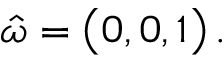Convert formula to latex. <formula><loc_0><loc_0><loc_500><loc_500>\hat { \omega } = \left ( 0 , 0 , 1 \right ) \, .</formula> 